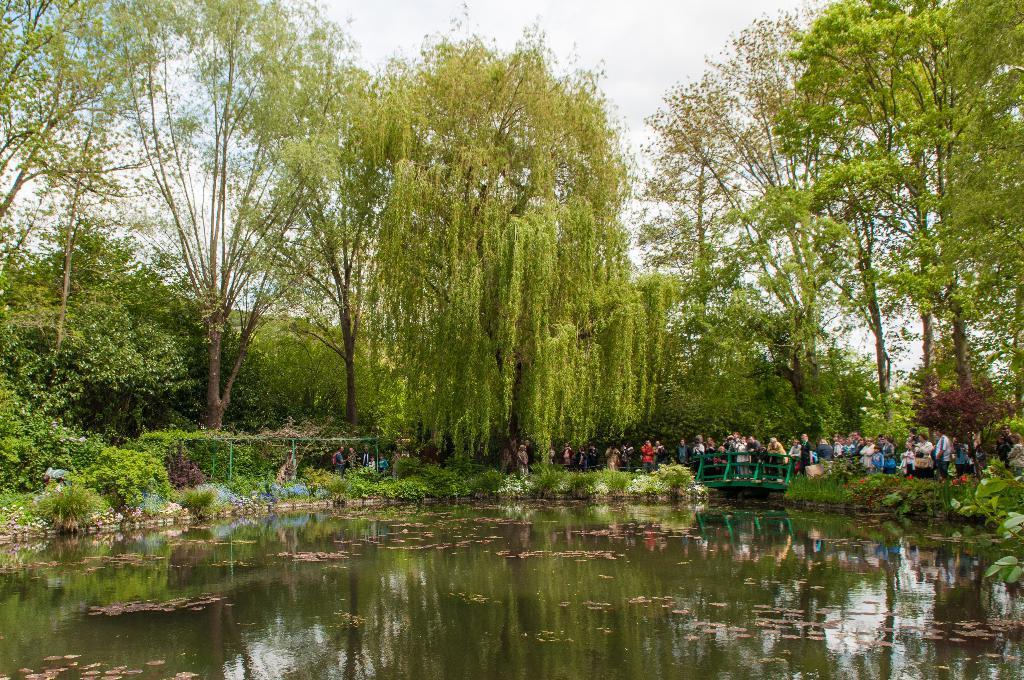Describe this image in one or two sentences. In this picture we can see small water pond in the front. Behind there are people standing and looking into the water. In the background we can see some huge trees. 